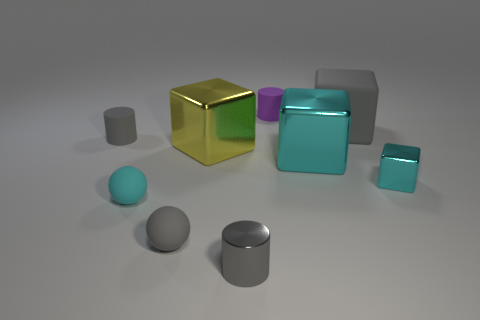Are the gray cube and the large yellow thing made of the same material?
Your answer should be compact. No. There is a gray cylinder on the left side of the big block on the left side of the matte cylinder behind the large rubber block; what size is it?
Keep it short and to the point. Small. How many other objects are there of the same color as the small cube?
Make the answer very short. 2. There is a cyan metal object that is the same size as the purple cylinder; what is its shape?
Keep it short and to the point. Cube. What number of small things are rubber cylinders or gray objects?
Ensure brevity in your answer.  4. Are there any small metallic objects on the left side of the tiny gray cylinder in front of the small block to the right of the large cyan metal thing?
Offer a terse response. No. Is there another rubber cylinder of the same size as the purple rubber cylinder?
Your response must be concise. Yes. There is a gray thing that is the same size as the yellow metallic block; what is its material?
Your answer should be very brief. Rubber. Does the gray block have the same size as the gray thing to the left of the cyan rubber thing?
Make the answer very short. No. How many metal things are big blocks or large yellow blocks?
Make the answer very short. 2. 